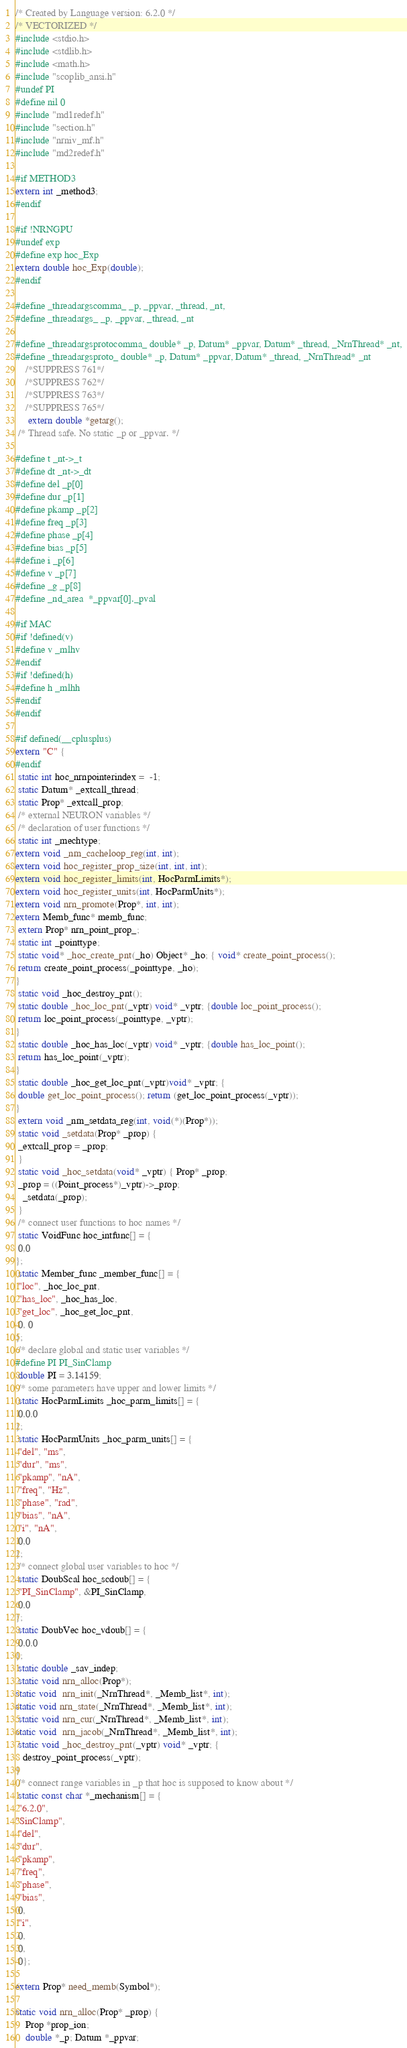<code> <loc_0><loc_0><loc_500><loc_500><_C_>/* Created by Language version: 6.2.0 */
/* VECTORIZED */
#include <stdio.h>
#include <stdlib.h>
#include <math.h>
#include "scoplib_ansi.h"
#undef PI
#define nil 0
#include "md1redef.h"
#include "section.h"
#include "nrniv_mf.h"
#include "md2redef.h"
 
#if METHOD3
extern int _method3;
#endif

#if !NRNGPU
#undef exp
#define exp hoc_Exp
extern double hoc_Exp(double);
#endif
 
#define _threadargscomma_ _p, _ppvar, _thread, _nt,
#define _threadargs_ _p, _ppvar, _thread, _nt
 
#define _threadargsprotocomma_ double* _p, Datum* _ppvar, Datum* _thread, _NrnThread* _nt,
#define _threadargsproto_ double* _p, Datum* _ppvar, Datum* _thread, _NrnThread* _nt
 	/*SUPPRESS 761*/
	/*SUPPRESS 762*/
	/*SUPPRESS 763*/
	/*SUPPRESS 765*/
	 extern double *getarg();
 /* Thread safe. No static _p or _ppvar. */
 
#define t _nt->_t
#define dt _nt->_dt
#define del _p[0]
#define dur _p[1]
#define pkamp _p[2]
#define freq _p[3]
#define phase _p[4]
#define bias _p[5]
#define i _p[6]
#define v _p[7]
#define _g _p[8]
#define _nd_area  *_ppvar[0]._pval
 
#if MAC
#if !defined(v)
#define v _mlhv
#endif
#if !defined(h)
#define h _mlhh
#endif
#endif
 
#if defined(__cplusplus)
extern "C" {
#endif
 static int hoc_nrnpointerindex =  -1;
 static Datum* _extcall_thread;
 static Prop* _extcall_prop;
 /* external NEURON variables */
 /* declaration of user functions */
 static int _mechtype;
extern void _nrn_cacheloop_reg(int, int);
extern void hoc_register_prop_size(int, int, int);
extern void hoc_register_limits(int, HocParmLimits*);
extern void hoc_register_units(int, HocParmUnits*);
extern void nrn_promote(Prop*, int, int);
extern Memb_func* memb_func;
 extern Prop* nrn_point_prop_;
 static int _pointtype;
 static void* _hoc_create_pnt(_ho) Object* _ho; { void* create_point_process();
 return create_point_process(_pointtype, _ho);
}
 static void _hoc_destroy_pnt();
 static double _hoc_loc_pnt(_vptr) void* _vptr; {double loc_point_process();
 return loc_point_process(_pointtype, _vptr);
}
 static double _hoc_has_loc(_vptr) void* _vptr; {double has_loc_point();
 return has_loc_point(_vptr);
}
 static double _hoc_get_loc_pnt(_vptr)void* _vptr; {
 double get_loc_point_process(); return (get_loc_point_process(_vptr));
}
 extern void _nrn_setdata_reg(int, void(*)(Prop*));
 static void _setdata(Prop* _prop) {
 _extcall_prop = _prop;
 }
 static void _hoc_setdata(void* _vptr) { Prop* _prop;
 _prop = ((Point_process*)_vptr)->_prop;
   _setdata(_prop);
 }
 /* connect user functions to hoc names */
 static VoidFunc hoc_intfunc[] = {
 0,0
};
 static Member_func _member_func[] = {
 "loc", _hoc_loc_pnt,
 "has_loc", _hoc_has_loc,
 "get_loc", _hoc_get_loc_pnt,
 0, 0
};
 /* declare global and static user variables */
#define PI PI_SinClamp
 double PI = 3.14159;
 /* some parameters have upper and lower limits */
 static HocParmLimits _hoc_parm_limits[] = {
 0,0,0
};
 static HocParmUnits _hoc_parm_units[] = {
 "del", "ms",
 "dur", "ms",
 "pkamp", "nA",
 "freq", "Hz",
 "phase", "rad",
 "bias", "nA",
 "i", "nA",
 0,0
};
 /* connect global user variables to hoc */
 static DoubScal hoc_scdoub[] = {
 "PI_SinClamp", &PI_SinClamp,
 0,0
};
 static DoubVec hoc_vdoub[] = {
 0,0,0
};
 static double _sav_indep;
 static void nrn_alloc(Prop*);
static void  nrn_init(_NrnThread*, _Memb_list*, int);
static void nrn_state(_NrnThread*, _Memb_list*, int);
 static void nrn_cur(_NrnThread*, _Memb_list*, int);
static void  nrn_jacob(_NrnThread*, _Memb_list*, int);
 static void _hoc_destroy_pnt(_vptr) void* _vptr; {
   destroy_point_process(_vptr);
}
 /* connect range variables in _p that hoc is supposed to know about */
 static const char *_mechanism[] = {
 "6.2.0",
"SinClamp",
 "del",
 "dur",
 "pkamp",
 "freq",
 "phase",
 "bias",
 0,
 "i",
 0,
 0,
 0};
 
extern Prop* need_memb(Symbol*);

static void nrn_alloc(Prop* _prop) {
	Prop *prop_ion;
	double *_p; Datum *_ppvar;</code> 